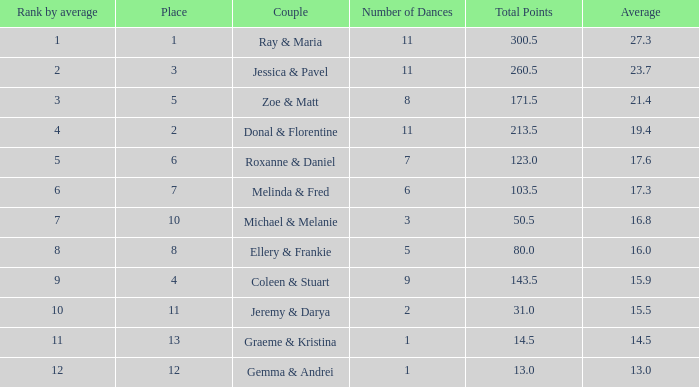If your average rank is less than 2.0, what would be your standing? 1.0. 